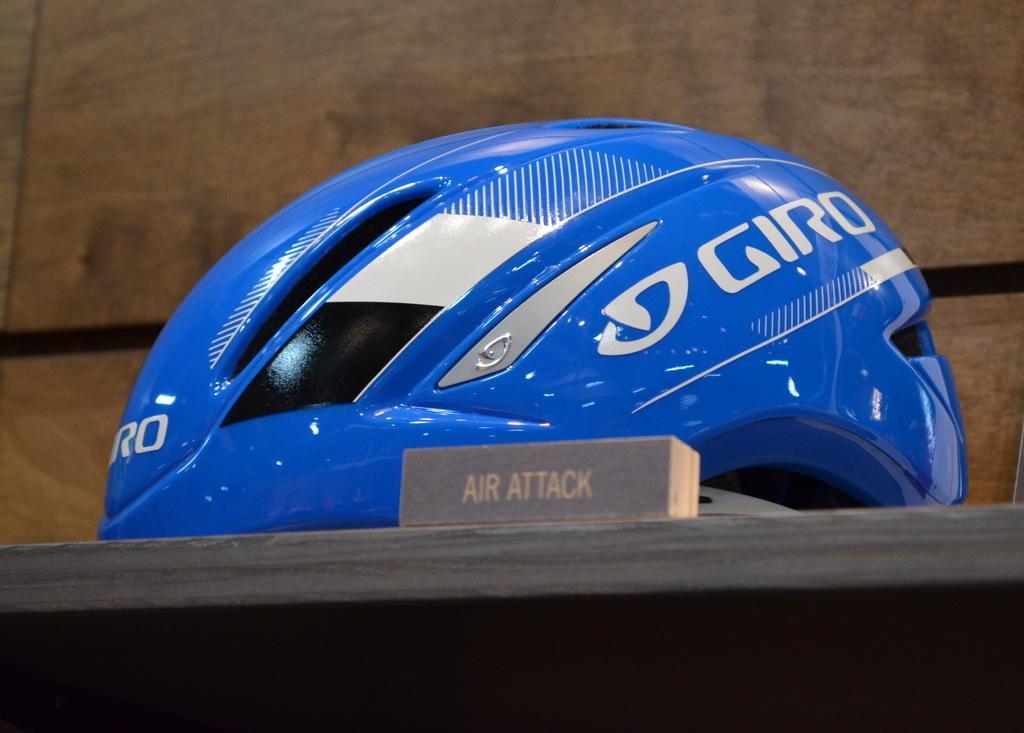Please provide a concise description of this image. This image consists of a helmet. It is in blue color. 